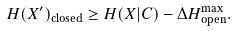Convert formula to latex. <formula><loc_0><loc_0><loc_500><loc_500>H ( X ^ { \prime } ) _ { \text {closed} } \geq H ( X | C ) - \Delta H _ { \text {open} } ^ { \max } .</formula> 